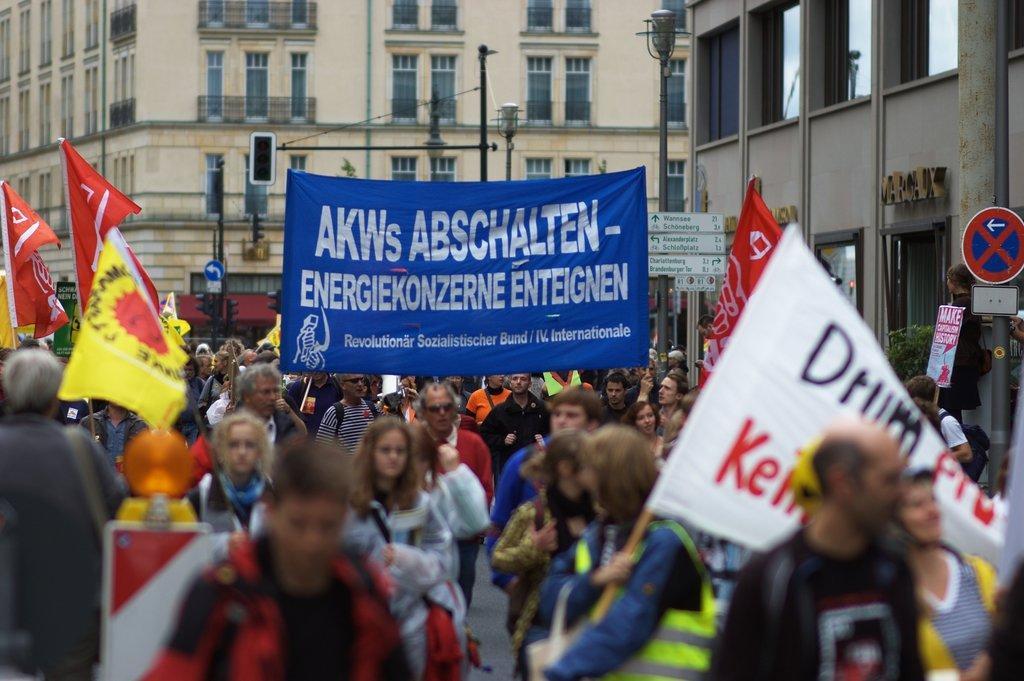Describe this image in one or two sentences. In this picture there is a group of people walking on the street and doing a protest. Above we can see a blue color banner and some posters. In the background there is a yellow color building with many windows. 